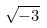<formula> <loc_0><loc_0><loc_500><loc_500>\sqrt { - 3 }</formula> 